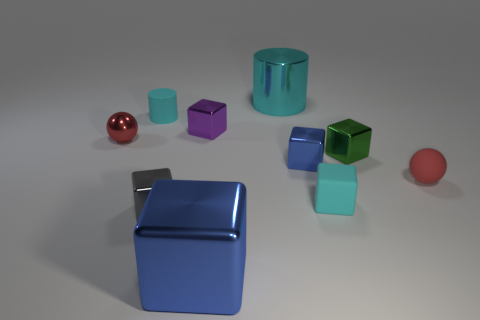Is the shape of the purple object the same as the large cyan thing? No, the shapes are different. The purple object is a cube while the large cyan object is a cylinder. 